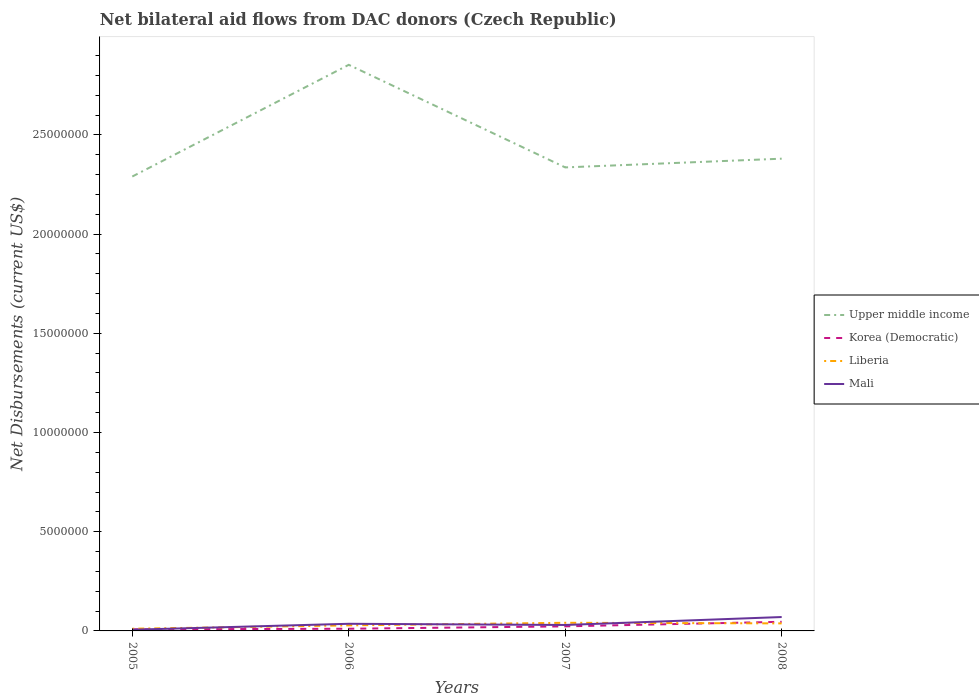How many different coloured lines are there?
Provide a short and direct response. 4. Across all years, what is the maximum net bilateral aid flows in Korea (Democratic)?
Give a very brief answer. 8.00e+04. What is the total net bilateral aid flows in Mali in the graph?
Keep it short and to the point. -2.40e+05. What is the difference between the highest and the second highest net bilateral aid flows in Mali?
Offer a very short reply. 6.40e+05. Is the net bilateral aid flows in Upper middle income strictly greater than the net bilateral aid flows in Liberia over the years?
Offer a very short reply. No. How many lines are there?
Ensure brevity in your answer.  4. Are the values on the major ticks of Y-axis written in scientific E-notation?
Give a very brief answer. No. Does the graph contain any zero values?
Your answer should be very brief. No. Does the graph contain grids?
Provide a short and direct response. No. What is the title of the graph?
Provide a short and direct response. Net bilateral aid flows from DAC donors (Czech Republic). What is the label or title of the Y-axis?
Your response must be concise. Net Disbursements (current US$). What is the Net Disbursements (current US$) in Upper middle income in 2005?
Ensure brevity in your answer.  2.29e+07. What is the Net Disbursements (current US$) of Liberia in 2005?
Provide a succinct answer. 1.10e+05. What is the Net Disbursements (current US$) of Upper middle income in 2006?
Provide a succinct answer. 2.85e+07. What is the Net Disbursements (current US$) in Mali in 2006?
Ensure brevity in your answer.  3.60e+05. What is the Net Disbursements (current US$) in Upper middle income in 2007?
Make the answer very short. 2.34e+07. What is the Net Disbursements (current US$) of Korea (Democratic) in 2007?
Provide a succinct answer. 2.30e+05. What is the Net Disbursements (current US$) of Mali in 2007?
Your answer should be compact. 3.00e+05. What is the Net Disbursements (current US$) in Upper middle income in 2008?
Offer a very short reply. 2.38e+07. What is the Net Disbursements (current US$) in Liberia in 2008?
Your answer should be very brief. 3.80e+05. What is the Net Disbursements (current US$) of Mali in 2008?
Your answer should be very brief. 7.00e+05. Across all years, what is the maximum Net Disbursements (current US$) of Upper middle income?
Give a very brief answer. 2.85e+07. Across all years, what is the maximum Net Disbursements (current US$) in Korea (Democratic)?
Provide a succinct answer. 4.60e+05. Across all years, what is the maximum Net Disbursements (current US$) of Liberia?
Offer a very short reply. 4.10e+05. Across all years, what is the minimum Net Disbursements (current US$) of Upper middle income?
Make the answer very short. 2.29e+07. What is the total Net Disbursements (current US$) in Upper middle income in the graph?
Your response must be concise. 9.86e+07. What is the total Net Disbursements (current US$) in Korea (Democratic) in the graph?
Ensure brevity in your answer.  8.80e+05. What is the total Net Disbursements (current US$) of Liberia in the graph?
Ensure brevity in your answer.  1.18e+06. What is the total Net Disbursements (current US$) in Mali in the graph?
Keep it short and to the point. 1.42e+06. What is the difference between the Net Disbursements (current US$) in Upper middle income in 2005 and that in 2006?
Your response must be concise. -5.63e+06. What is the difference between the Net Disbursements (current US$) of Liberia in 2005 and that in 2006?
Your response must be concise. -1.70e+05. What is the difference between the Net Disbursements (current US$) of Upper middle income in 2005 and that in 2007?
Keep it short and to the point. -4.60e+05. What is the difference between the Net Disbursements (current US$) of Korea (Democratic) in 2005 and that in 2007?
Offer a terse response. -1.50e+05. What is the difference between the Net Disbursements (current US$) in Liberia in 2005 and that in 2007?
Your answer should be very brief. -3.00e+05. What is the difference between the Net Disbursements (current US$) in Upper middle income in 2005 and that in 2008?
Keep it short and to the point. -9.00e+05. What is the difference between the Net Disbursements (current US$) of Korea (Democratic) in 2005 and that in 2008?
Offer a very short reply. -3.80e+05. What is the difference between the Net Disbursements (current US$) in Liberia in 2005 and that in 2008?
Your answer should be compact. -2.70e+05. What is the difference between the Net Disbursements (current US$) in Mali in 2005 and that in 2008?
Offer a terse response. -6.40e+05. What is the difference between the Net Disbursements (current US$) of Upper middle income in 2006 and that in 2007?
Make the answer very short. 5.17e+06. What is the difference between the Net Disbursements (current US$) of Korea (Democratic) in 2006 and that in 2007?
Provide a short and direct response. -1.20e+05. What is the difference between the Net Disbursements (current US$) in Liberia in 2006 and that in 2007?
Make the answer very short. -1.30e+05. What is the difference between the Net Disbursements (current US$) in Mali in 2006 and that in 2007?
Your answer should be very brief. 6.00e+04. What is the difference between the Net Disbursements (current US$) in Upper middle income in 2006 and that in 2008?
Offer a very short reply. 4.73e+06. What is the difference between the Net Disbursements (current US$) of Korea (Democratic) in 2006 and that in 2008?
Give a very brief answer. -3.50e+05. What is the difference between the Net Disbursements (current US$) of Upper middle income in 2007 and that in 2008?
Provide a succinct answer. -4.40e+05. What is the difference between the Net Disbursements (current US$) of Mali in 2007 and that in 2008?
Provide a succinct answer. -4.00e+05. What is the difference between the Net Disbursements (current US$) of Upper middle income in 2005 and the Net Disbursements (current US$) of Korea (Democratic) in 2006?
Offer a very short reply. 2.28e+07. What is the difference between the Net Disbursements (current US$) in Upper middle income in 2005 and the Net Disbursements (current US$) in Liberia in 2006?
Your answer should be compact. 2.26e+07. What is the difference between the Net Disbursements (current US$) of Upper middle income in 2005 and the Net Disbursements (current US$) of Mali in 2006?
Offer a terse response. 2.25e+07. What is the difference between the Net Disbursements (current US$) of Korea (Democratic) in 2005 and the Net Disbursements (current US$) of Liberia in 2006?
Make the answer very short. -2.00e+05. What is the difference between the Net Disbursements (current US$) in Korea (Democratic) in 2005 and the Net Disbursements (current US$) in Mali in 2006?
Your response must be concise. -2.80e+05. What is the difference between the Net Disbursements (current US$) of Liberia in 2005 and the Net Disbursements (current US$) of Mali in 2006?
Keep it short and to the point. -2.50e+05. What is the difference between the Net Disbursements (current US$) in Upper middle income in 2005 and the Net Disbursements (current US$) in Korea (Democratic) in 2007?
Keep it short and to the point. 2.27e+07. What is the difference between the Net Disbursements (current US$) in Upper middle income in 2005 and the Net Disbursements (current US$) in Liberia in 2007?
Provide a succinct answer. 2.25e+07. What is the difference between the Net Disbursements (current US$) in Upper middle income in 2005 and the Net Disbursements (current US$) in Mali in 2007?
Keep it short and to the point. 2.26e+07. What is the difference between the Net Disbursements (current US$) of Korea (Democratic) in 2005 and the Net Disbursements (current US$) of Liberia in 2007?
Offer a very short reply. -3.30e+05. What is the difference between the Net Disbursements (current US$) in Korea (Democratic) in 2005 and the Net Disbursements (current US$) in Mali in 2007?
Your response must be concise. -2.20e+05. What is the difference between the Net Disbursements (current US$) of Liberia in 2005 and the Net Disbursements (current US$) of Mali in 2007?
Provide a short and direct response. -1.90e+05. What is the difference between the Net Disbursements (current US$) of Upper middle income in 2005 and the Net Disbursements (current US$) of Korea (Democratic) in 2008?
Your answer should be very brief. 2.24e+07. What is the difference between the Net Disbursements (current US$) in Upper middle income in 2005 and the Net Disbursements (current US$) in Liberia in 2008?
Provide a succinct answer. 2.25e+07. What is the difference between the Net Disbursements (current US$) in Upper middle income in 2005 and the Net Disbursements (current US$) in Mali in 2008?
Your answer should be compact. 2.22e+07. What is the difference between the Net Disbursements (current US$) of Korea (Democratic) in 2005 and the Net Disbursements (current US$) of Liberia in 2008?
Your response must be concise. -3.00e+05. What is the difference between the Net Disbursements (current US$) of Korea (Democratic) in 2005 and the Net Disbursements (current US$) of Mali in 2008?
Your answer should be very brief. -6.20e+05. What is the difference between the Net Disbursements (current US$) of Liberia in 2005 and the Net Disbursements (current US$) of Mali in 2008?
Your answer should be compact. -5.90e+05. What is the difference between the Net Disbursements (current US$) of Upper middle income in 2006 and the Net Disbursements (current US$) of Korea (Democratic) in 2007?
Provide a short and direct response. 2.83e+07. What is the difference between the Net Disbursements (current US$) in Upper middle income in 2006 and the Net Disbursements (current US$) in Liberia in 2007?
Your answer should be compact. 2.81e+07. What is the difference between the Net Disbursements (current US$) of Upper middle income in 2006 and the Net Disbursements (current US$) of Mali in 2007?
Make the answer very short. 2.82e+07. What is the difference between the Net Disbursements (current US$) in Korea (Democratic) in 2006 and the Net Disbursements (current US$) in Liberia in 2007?
Keep it short and to the point. -3.00e+05. What is the difference between the Net Disbursements (current US$) in Liberia in 2006 and the Net Disbursements (current US$) in Mali in 2007?
Give a very brief answer. -2.00e+04. What is the difference between the Net Disbursements (current US$) in Upper middle income in 2006 and the Net Disbursements (current US$) in Korea (Democratic) in 2008?
Make the answer very short. 2.81e+07. What is the difference between the Net Disbursements (current US$) in Upper middle income in 2006 and the Net Disbursements (current US$) in Liberia in 2008?
Keep it short and to the point. 2.82e+07. What is the difference between the Net Disbursements (current US$) in Upper middle income in 2006 and the Net Disbursements (current US$) in Mali in 2008?
Give a very brief answer. 2.78e+07. What is the difference between the Net Disbursements (current US$) of Korea (Democratic) in 2006 and the Net Disbursements (current US$) of Mali in 2008?
Ensure brevity in your answer.  -5.90e+05. What is the difference between the Net Disbursements (current US$) of Liberia in 2006 and the Net Disbursements (current US$) of Mali in 2008?
Make the answer very short. -4.20e+05. What is the difference between the Net Disbursements (current US$) of Upper middle income in 2007 and the Net Disbursements (current US$) of Korea (Democratic) in 2008?
Offer a very short reply. 2.29e+07. What is the difference between the Net Disbursements (current US$) in Upper middle income in 2007 and the Net Disbursements (current US$) in Liberia in 2008?
Offer a terse response. 2.30e+07. What is the difference between the Net Disbursements (current US$) of Upper middle income in 2007 and the Net Disbursements (current US$) of Mali in 2008?
Keep it short and to the point. 2.27e+07. What is the difference between the Net Disbursements (current US$) in Korea (Democratic) in 2007 and the Net Disbursements (current US$) in Mali in 2008?
Offer a terse response. -4.70e+05. What is the difference between the Net Disbursements (current US$) in Liberia in 2007 and the Net Disbursements (current US$) in Mali in 2008?
Offer a terse response. -2.90e+05. What is the average Net Disbursements (current US$) in Upper middle income per year?
Your answer should be very brief. 2.46e+07. What is the average Net Disbursements (current US$) in Liberia per year?
Ensure brevity in your answer.  2.95e+05. What is the average Net Disbursements (current US$) of Mali per year?
Offer a very short reply. 3.55e+05. In the year 2005, what is the difference between the Net Disbursements (current US$) of Upper middle income and Net Disbursements (current US$) of Korea (Democratic)?
Ensure brevity in your answer.  2.28e+07. In the year 2005, what is the difference between the Net Disbursements (current US$) in Upper middle income and Net Disbursements (current US$) in Liberia?
Give a very brief answer. 2.28e+07. In the year 2005, what is the difference between the Net Disbursements (current US$) in Upper middle income and Net Disbursements (current US$) in Mali?
Keep it short and to the point. 2.28e+07. In the year 2005, what is the difference between the Net Disbursements (current US$) of Korea (Democratic) and Net Disbursements (current US$) of Mali?
Provide a succinct answer. 2.00e+04. In the year 2005, what is the difference between the Net Disbursements (current US$) of Liberia and Net Disbursements (current US$) of Mali?
Offer a very short reply. 5.00e+04. In the year 2006, what is the difference between the Net Disbursements (current US$) in Upper middle income and Net Disbursements (current US$) in Korea (Democratic)?
Your response must be concise. 2.84e+07. In the year 2006, what is the difference between the Net Disbursements (current US$) in Upper middle income and Net Disbursements (current US$) in Liberia?
Your answer should be very brief. 2.82e+07. In the year 2006, what is the difference between the Net Disbursements (current US$) of Upper middle income and Net Disbursements (current US$) of Mali?
Your answer should be very brief. 2.82e+07. In the year 2006, what is the difference between the Net Disbursements (current US$) of Korea (Democratic) and Net Disbursements (current US$) of Liberia?
Make the answer very short. -1.70e+05. In the year 2006, what is the difference between the Net Disbursements (current US$) of Korea (Democratic) and Net Disbursements (current US$) of Mali?
Provide a short and direct response. -2.50e+05. In the year 2006, what is the difference between the Net Disbursements (current US$) in Liberia and Net Disbursements (current US$) in Mali?
Provide a succinct answer. -8.00e+04. In the year 2007, what is the difference between the Net Disbursements (current US$) of Upper middle income and Net Disbursements (current US$) of Korea (Democratic)?
Provide a short and direct response. 2.31e+07. In the year 2007, what is the difference between the Net Disbursements (current US$) in Upper middle income and Net Disbursements (current US$) in Liberia?
Give a very brief answer. 2.30e+07. In the year 2007, what is the difference between the Net Disbursements (current US$) of Upper middle income and Net Disbursements (current US$) of Mali?
Keep it short and to the point. 2.31e+07. In the year 2007, what is the difference between the Net Disbursements (current US$) in Liberia and Net Disbursements (current US$) in Mali?
Offer a very short reply. 1.10e+05. In the year 2008, what is the difference between the Net Disbursements (current US$) of Upper middle income and Net Disbursements (current US$) of Korea (Democratic)?
Provide a succinct answer. 2.33e+07. In the year 2008, what is the difference between the Net Disbursements (current US$) in Upper middle income and Net Disbursements (current US$) in Liberia?
Offer a terse response. 2.34e+07. In the year 2008, what is the difference between the Net Disbursements (current US$) of Upper middle income and Net Disbursements (current US$) of Mali?
Offer a terse response. 2.31e+07. In the year 2008, what is the difference between the Net Disbursements (current US$) in Korea (Democratic) and Net Disbursements (current US$) in Liberia?
Keep it short and to the point. 8.00e+04. In the year 2008, what is the difference between the Net Disbursements (current US$) in Korea (Democratic) and Net Disbursements (current US$) in Mali?
Your answer should be very brief. -2.40e+05. In the year 2008, what is the difference between the Net Disbursements (current US$) in Liberia and Net Disbursements (current US$) in Mali?
Give a very brief answer. -3.20e+05. What is the ratio of the Net Disbursements (current US$) in Upper middle income in 2005 to that in 2006?
Give a very brief answer. 0.8. What is the ratio of the Net Disbursements (current US$) of Korea (Democratic) in 2005 to that in 2006?
Give a very brief answer. 0.73. What is the ratio of the Net Disbursements (current US$) in Liberia in 2005 to that in 2006?
Your answer should be very brief. 0.39. What is the ratio of the Net Disbursements (current US$) in Mali in 2005 to that in 2006?
Your response must be concise. 0.17. What is the ratio of the Net Disbursements (current US$) of Upper middle income in 2005 to that in 2007?
Keep it short and to the point. 0.98. What is the ratio of the Net Disbursements (current US$) in Korea (Democratic) in 2005 to that in 2007?
Your answer should be compact. 0.35. What is the ratio of the Net Disbursements (current US$) in Liberia in 2005 to that in 2007?
Your answer should be compact. 0.27. What is the ratio of the Net Disbursements (current US$) in Mali in 2005 to that in 2007?
Make the answer very short. 0.2. What is the ratio of the Net Disbursements (current US$) of Upper middle income in 2005 to that in 2008?
Provide a succinct answer. 0.96. What is the ratio of the Net Disbursements (current US$) in Korea (Democratic) in 2005 to that in 2008?
Keep it short and to the point. 0.17. What is the ratio of the Net Disbursements (current US$) of Liberia in 2005 to that in 2008?
Provide a succinct answer. 0.29. What is the ratio of the Net Disbursements (current US$) of Mali in 2005 to that in 2008?
Make the answer very short. 0.09. What is the ratio of the Net Disbursements (current US$) in Upper middle income in 2006 to that in 2007?
Offer a very short reply. 1.22. What is the ratio of the Net Disbursements (current US$) of Korea (Democratic) in 2006 to that in 2007?
Offer a terse response. 0.48. What is the ratio of the Net Disbursements (current US$) of Liberia in 2006 to that in 2007?
Provide a short and direct response. 0.68. What is the ratio of the Net Disbursements (current US$) in Upper middle income in 2006 to that in 2008?
Your answer should be compact. 1.2. What is the ratio of the Net Disbursements (current US$) of Korea (Democratic) in 2006 to that in 2008?
Provide a succinct answer. 0.24. What is the ratio of the Net Disbursements (current US$) of Liberia in 2006 to that in 2008?
Your response must be concise. 0.74. What is the ratio of the Net Disbursements (current US$) in Mali in 2006 to that in 2008?
Offer a very short reply. 0.51. What is the ratio of the Net Disbursements (current US$) in Upper middle income in 2007 to that in 2008?
Ensure brevity in your answer.  0.98. What is the ratio of the Net Disbursements (current US$) of Liberia in 2007 to that in 2008?
Your answer should be very brief. 1.08. What is the ratio of the Net Disbursements (current US$) of Mali in 2007 to that in 2008?
Ensure brevity in your answer.  0.43. What is the difference between the highest and the second highest Net Disbursements (current US$) of Upper middle income?
Your answer should be very brief. 4.73e+06. What is the difference between the highest and the second highest Net Disbursements (current US$) of Liberia?
Give a very brief answer. 3.00e+04. What is the difference between the highest and the lowest Net Disbursements (current US$) in Upper middle income?
Your answer should be very brief. 5.63e+06. What is the difference between the highest and the lowest Net Disbursements (current US$) in Mali?
Provide a short and direct response. 6.40e+05. 